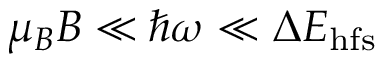<formula> <loc_0><loc_0><loc_500><loc_500>\mu _ { B } B \ll \hbar { \omega } \ll \Delta E _ { h f s }</formula> 